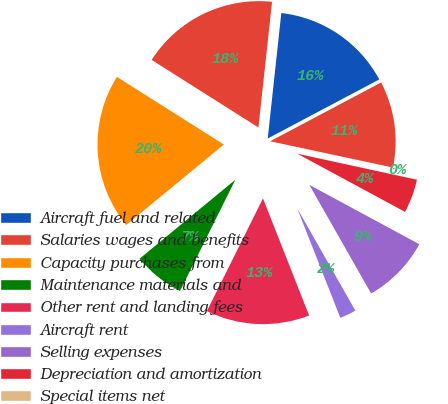<chart> <loc_0><loc_0><loc_500><loc_500><pie_chart><fcel>Aircraft fuel and related<fcel>Salaries wages and benefits<fcel>Capacity purchases from<fcel>Maintenance materials and<fcel>Other rent and landing fees<fcel>Aircraft rent<fcel>Selling expenses<fcel>Depreciation and amortization<fcel>Special items net<fcel>Other<nl><fcel>15.53%<fcel>17.74%<fcel>19.95%<fcel>6.68%<fcel>13.32%<fcel>2.26%<fcel>8.89%<fcel>4.47%<fcel>0.05%<fcel>11.11%<nl></chart> 